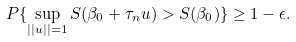<formula> <loc_0><loc_0><loc_500><loc_500>P \{ \sup _ { | | u | | = 1 } S ( \beta _ { 0 } + \tau _ { n } u ) > S ( \beta _ { 0 } ) \} \geq 1 - \epsilon .</formula> 